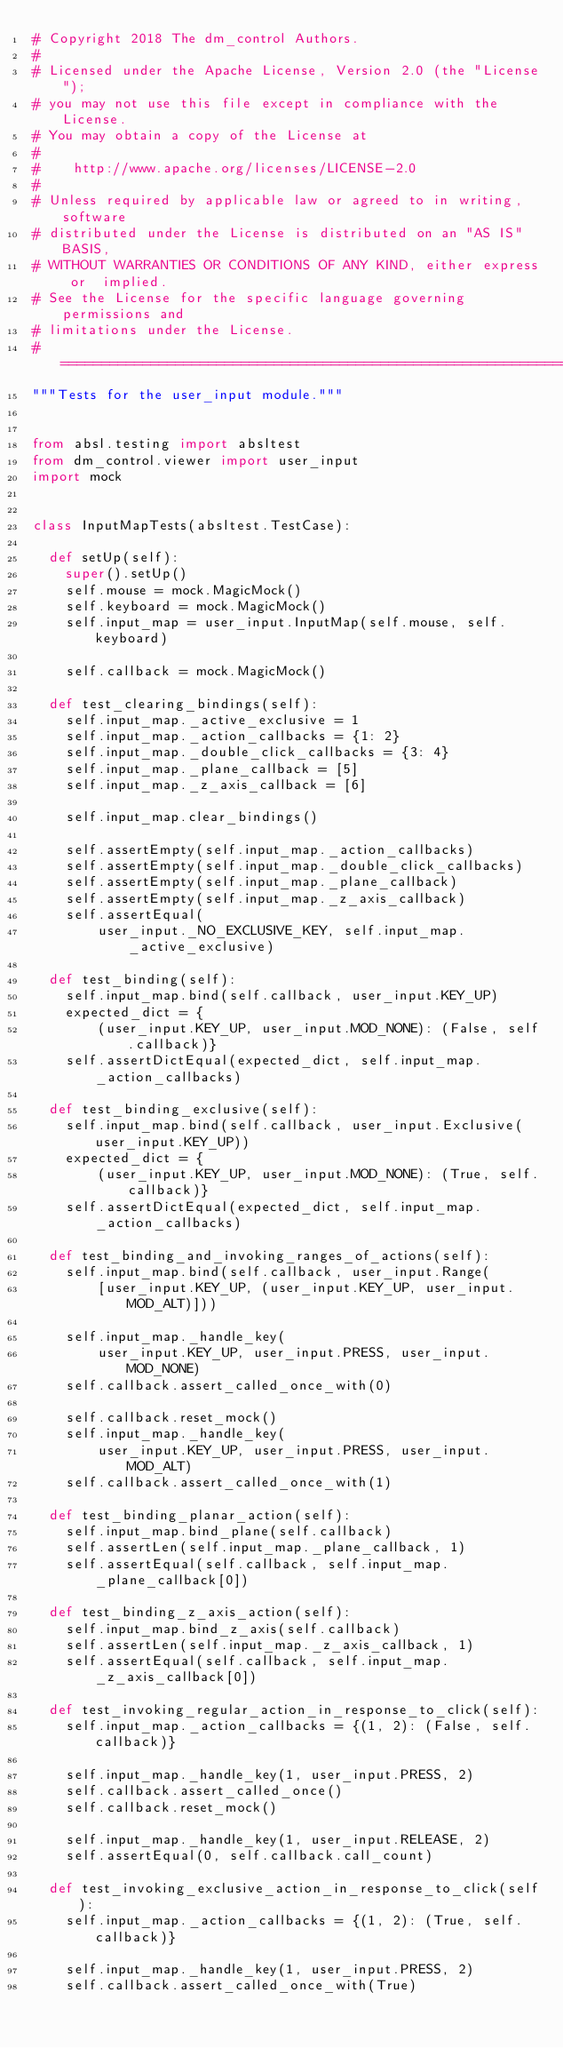<code> <loc_0><loc_0><loc_500><loc_500><_Python_># Copyright 2018 The dm_control Authors.
#
# Licensed under the Apache License, Version 2.0 (the "License");
# you may not use this file except in compliance with the License.
# You may obtain a copy of the License at
#
#    http://www.apache.org/licenses/LICENSE-2.0
#
# Unless required by applicable law or agreed to in writing, software
# distributed under the License is distributed on an "AS IS" BASIS,
# WITHOUT WARRANTIES OR CONDITIONS OF ANY KIND, either express or  implied.
# See the License for the specific language governing permissions and
# limitations under the License.
# ============================================================================
"""Tests for the user_input module."""


from absl.testing import absltest
from dm_control.viewer import user_input
import mock


class InputMapTests(absltest.TestCase):

  def setUp(self):
    super().setUp()
    self.mouse = mock.MagicMock()
    self.keyboard = mock.MagicMock()
    self.input_map = user_input.InputMap(self.mouse, self.keyboard)

    self.callback = mock.MagicMock()

  def test_clearing_bindings(self):
    self.input_map._active_exclusive = 1
    self.input_map._action_callbacks = {1: 2}
    self.input_map._double_click_callbacks = {3: 4}
    self.input_map._plane_callback = [5]
    self.input_map._z_axis_callback = [6]

    self.input_map.clear_bindings()

    self.assertEmpty(self.input_map._action_callbacks)
    self.assertEmpty(self.input_map._double_click_callbacks)
    self.assertEmpty(self.input_map._plane_callback)
    self.assertEmpty(self.input_map._z_axis_callback)
    self.assertEqual(
        user_input._NO_EXCLUSIVE_KEY, self.input_map._active_exclusive)

  def test_binding(self):
    self.input_map.bind(self.callback, user_input.KEY_UP)
    expected_dict = {
        (user_input.KEY_UP, user_input.MOD_NONE): (False, self.callback)}
    self.assertDictEqual(expected_dict, self.input_map._action_callbacks)

  def test_binding_exclusive(self):
    self.input_map.bind(self.callback, user_input.Exclusive(user_input.KEY_UP))
    expected_dict = {
        (user_input.KEY_UP, user_input.MOD_NONE): (True, self.callback)}
    self.assertDictEqual(expected_dict, self.input_map._action_callbacks)

  def test_binding_and_invoking_ranges_of_actions(self):
    self.input_map.bind(self.callback, user_input.Range(
        [user_input.KEY_UP, (user_input.KEY_UP, user_input.MOD_ALT)]))

    self.input_map._handle_key(
        user_input.KEY_UP, user_input.PRESS, user_input.MOD_NONE)
    self.callback.assert_called_once_with(0)

    self.callback.reset_mock()
    self.input_map._handle_key(
        user_input.KEY_UP, user_input.PRESS, user_input.MOD_ALT)
    self.callback.assert_called_once_with(1)

  def test_binding_planar_action(self):
    self.input_map.bind_plane(self.callback)
    self.assertLen(self.input_map._plane_callback, 1)
    self.assertEqual(self.callback, self.input_map._plane_callback[0])

  def test_binding_z_axis_action(self):
    self.input_map.bind_z_axis(self.callback)
    self.assertLen(self.input_map._z_axis_callback, 1)
    self.assertEqual(self.callback, self.input_map._z_axis_callback[0])

  def test_invoking_regular_action_in_response_to_click(self):
    self.input_map._action_callbacks = {(1, 2): (False, self.callback)}

    self.input_map._handle_key(1, user_input.PRESS, 2)
    self.callback.assert_called_once()
    self.callback.reset_mock()

    self.input_map._handle_key(1, user_input.RELEASE, 2)
    self.assertEqual(0, self.callback.call_count)

  def test_invoking_exclusive_action_in_response_to_click(self):
    self.input_map._action_callbacks = {(1, 2): (True, self.callback)}

    self.input_map._handle_key(1, user_input.PRESS, 2)
    self.callback.assert_called_once_with(True)</code> 